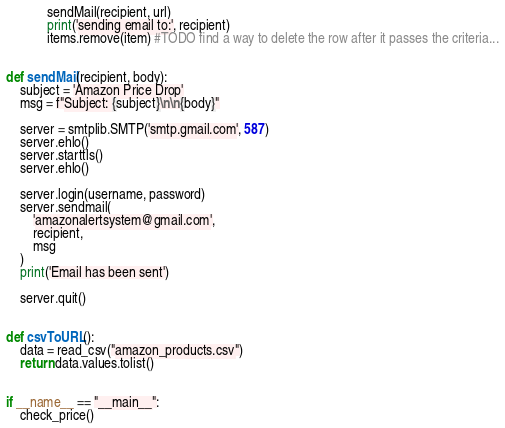<code> <loc_0><loc_0><loc_500><loc_500><_Python_>            sendMail(recipient, url)
            print('sending email to:', recipient)
            items.remove(item) #TODO find a way to delete the row after it passes the criteria...


def sendMail(recipient, body):
    subject = 'Amazon Price Drop'
    msg = f"Subject: {subject}\n\n{body}"

    server = smtplib.SMTP('smtp.gmail.com', 587)
    server.ehlo()
    server.starttls()
    server.ehlo()

    server.login(username, password)
    server.sendmail(
        'amazonalertsystem@gmail.com',
        recipient,
        msg
    )
    print('Email has been sent')

    server.quit()


def csvToURL():
    data = read_csv("amazon_products.csv")
    return data.values.tolist()


if __name__ == "__main__":
    check_price()
</code> 